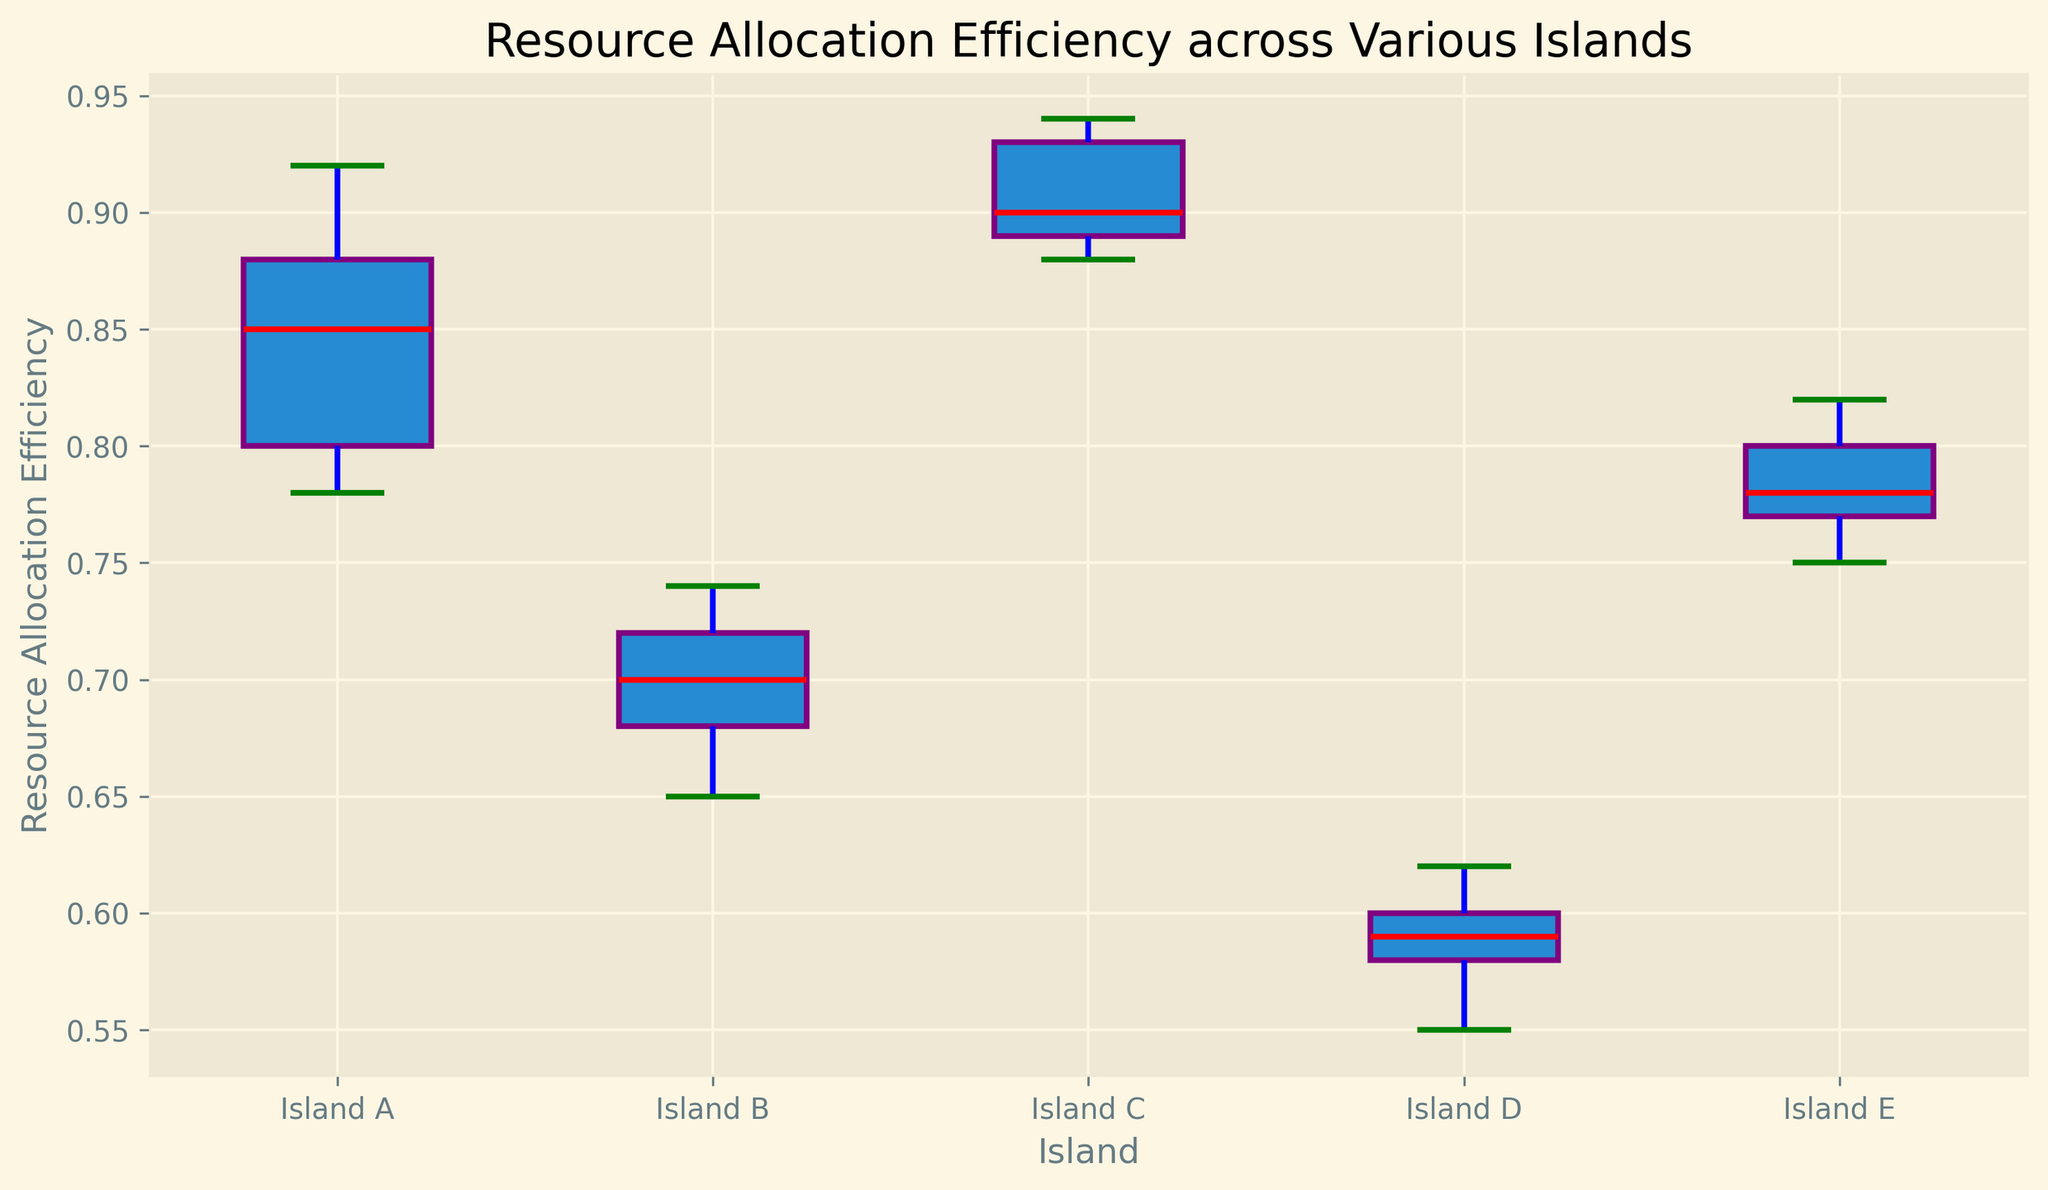What does the median line within the box represent? The median line within the box represents the middle value of the Resource Allocation Efficiency within each island, separating the higher half from the lower half.
Answer: The middle value of the data Which island has the highest median Resource Allocation Efficiency? By looking at the median lines in the boxes, Island C has the highest median Resource Allocation Efficiency, as its red line is the highest compared to other islands.
Answer: Island C Compare the medians of Island B and Island D. Which one is higher? The median of Island B is higher than the median of Island D, as the red line within the box for Island B is positioned higher than that of Island D.
Answer: Island B What color represents the whiskers in the plot? The whiskers, which extend from the boxes to show the range of the data excluding outliers, are represented in the color blue.
Answer: Blue Which island shows the most variability in Resource Allocation Efficiency? Island A shows the most variability, as indicated by the longer whiskers, suggesting a wider range of data points.
Answer: Island A Is there any outlier observed in the data? No visible flier markers (orange circles) indicate outliers in the data for any of the islands.
Answer: No Which island has the lowest minimum Resource Allocation Efficiency? Island D has the lowest minimum Resource Allocation Efficiency, as indicated by the bottom whisker of its box plot.
Answer: Island D How does the interquartile range (IQR) of Island E compare to Island B? The IQR of Island E (the length of the box) is slightly larger than that of Island B, indicating a wider spread of the middle 50% of the data points in Island E.
Answer: Larger What does the height of a box in a box plot generally indicate? The height of a box in a box plot indicates the interquartile range (IQR), which represents the middle 50% of the data. A taller box suggests more variability within that range.
Answer: Interquartile range (IQR) Compare the top whisker lengths of Island A and Island C. Which one is longer? The top whisker of Island A is longer than that of Island C, indicating that the maximum value in Island A is farther from its median than in Island C.
Answer: Island A 